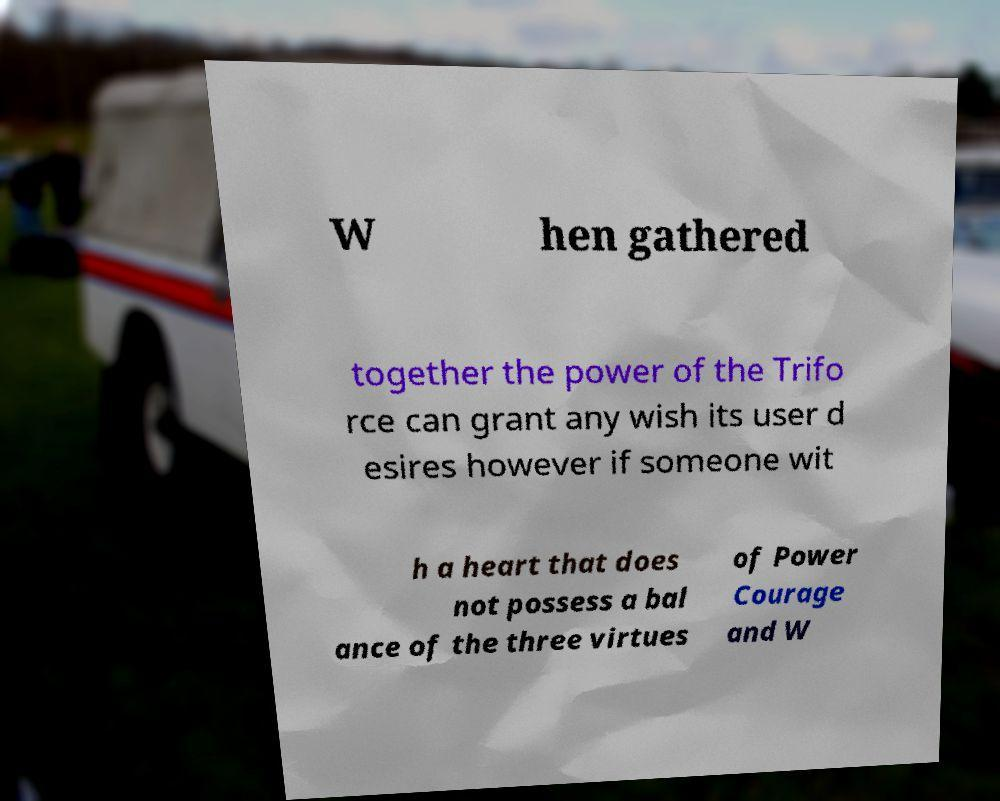Can you accurately transcribe the text from the provided image for me? W hen gathered together the power of the Trifo rce can grant any wish its user d esires however if someone wit h a heart that does not possess a bal ance of the three virtues of Power Courage and W 